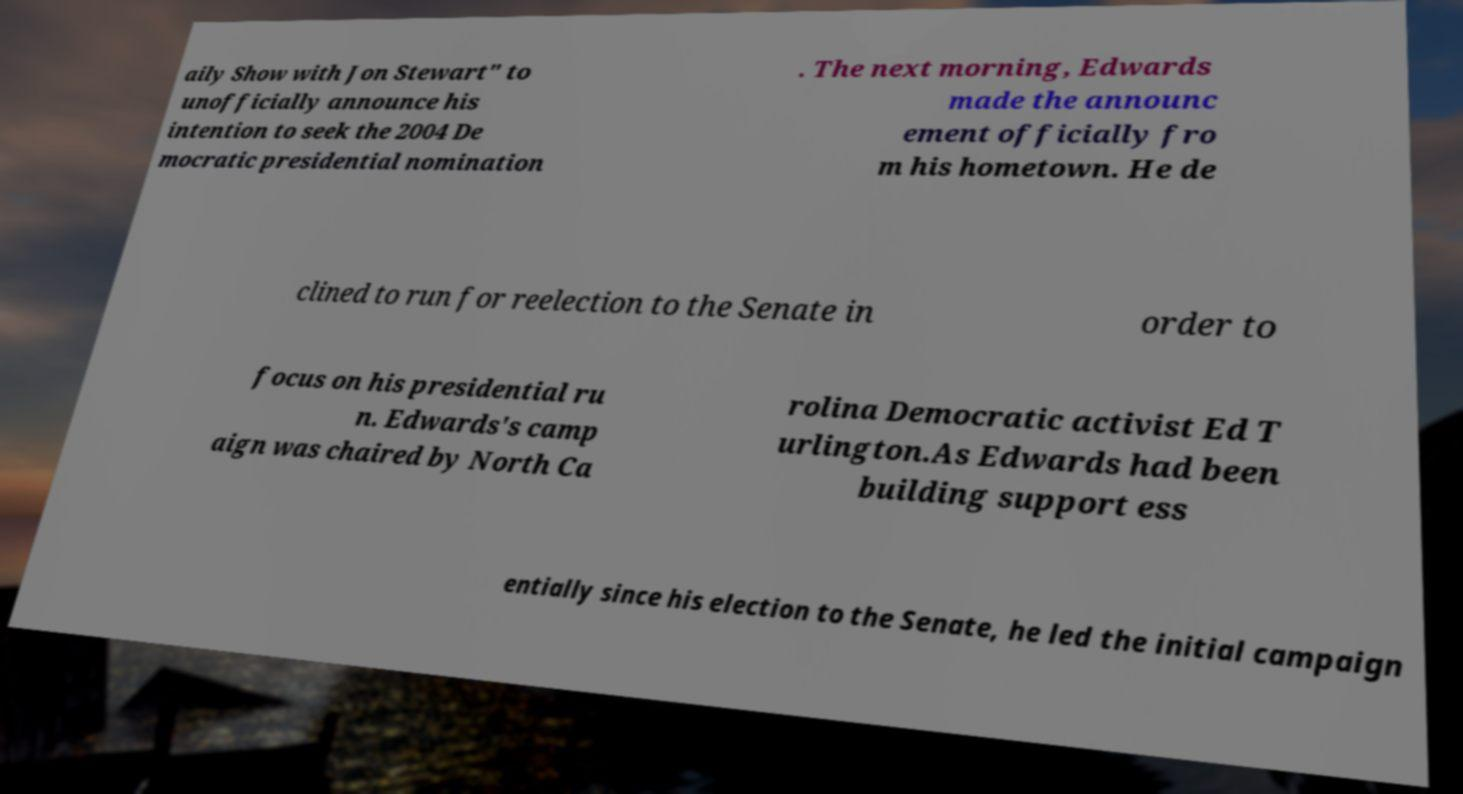Could you assist in decoding the text presented in this image and type it out clearly? aily Show with Jon Stewart" to unofficially announce his intention to seek the 2004 De mocratic presidential nomination . The next morning, Edwards made the announc ement officially fro m his hometown. He de clined to run for reelection to the Senate in order to focus on his presidential ru n. Edwards's camp aign was chaired by North Ca rolina Democratic activist Ed T urlington.As Edwards had been building support ess entially since his election to the Senate, he led the initial campaign 